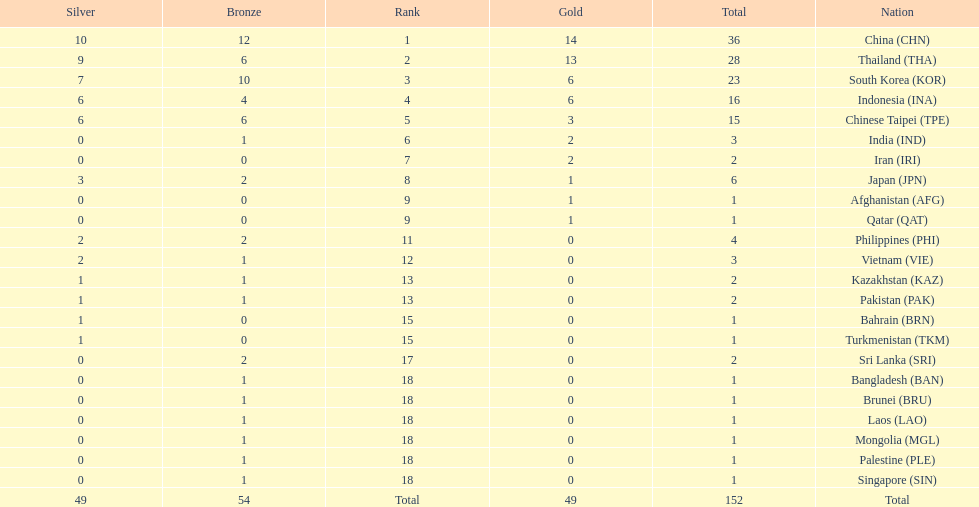How many more medals did india earn compared to pakistan? 1. 